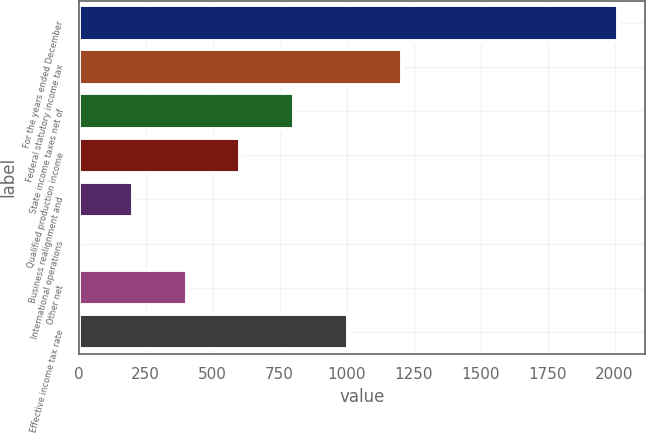Convert chart. <chart><loc_0><loc_0><loc_500><loc_500><bar_chart><fcel>For the years ended December<fcel>Federal statutory income tax<fcel>State income taxes net of<fcel>Qualified production income<fcel>Business realignment and<fcel>International operations<fcel>Other net<fcel>Effective income tax rate<nl><fcel>2012<fcel>1207.24<fcel>804.86<fcel>603.67<fcel>201.29<fcel>0.1<fcel>402.48<fcel>1006.05<nl></chart> 